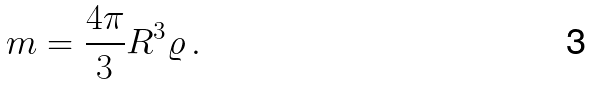<formula> <loc_0><loc_0><loc_500><loc_500>m = \frac { 4 \pi } { 3 } R ^ { 3 } \varrho \, .</formula> 